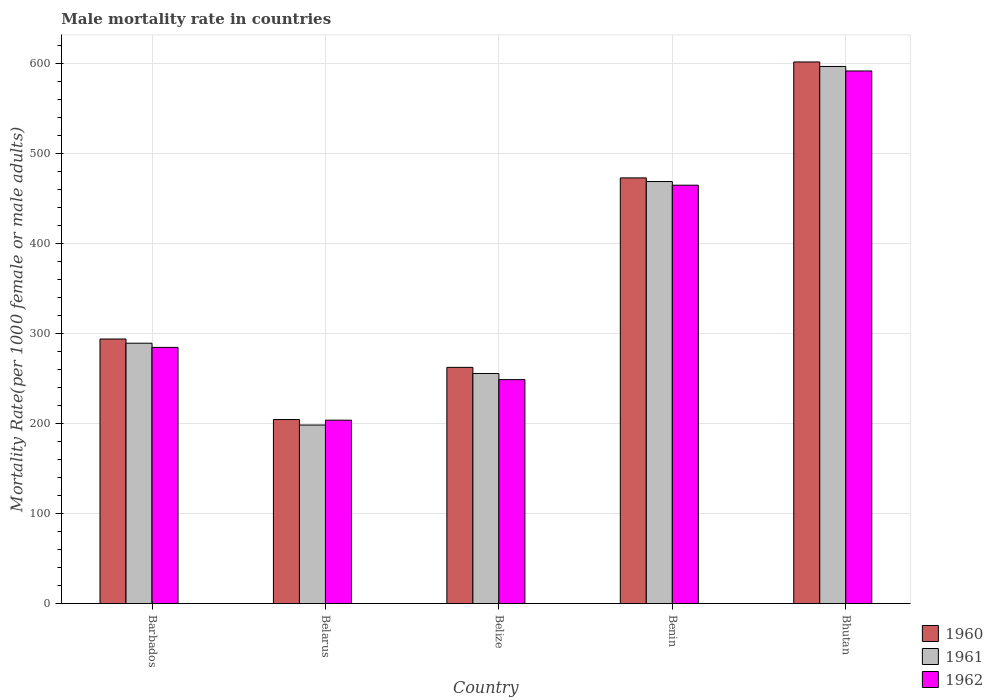Are the number of bars per tick equal to the number of legend labels?
Make the answer very short. Yes. How many bars are there on the 3rd tick from the right?
Your answer should be very brief. 3. What is the label of the 2nd group of bars from the left?
Provide a short and direct response. Belarus. What is the male mortality rate in 1960 in Benin?
Offer a very short reply. 473.24. Across all countries, what is the maximum male mortality rate in 1960?
Give a very brief answer. 602.1. Across all countries, what is the minimum male mortality rate in 1961?
Provide a succinct answer. 198.55. In which country was the male mortality rate in 1960 maximum?
Provide a short and direct response. Bhutan. In which country was the male mortality rate in 1961 minimum?
Offer a terse response. Belarus. What is the total male mortality rate in 1960 in the graph?
Keep it short and to the point. 1836.76. What is the difference between the male mortality rate in 1960 in Barbados and that in Belarus?
Provide a short and direct response. 89.49. What is the difference between the male mortality rate in 1962 in Bhutan and the male mortality rate in 1960 in Belarus?
Offer a terse response. 387.43. What is the average male mortality rate in 1962 per country?
Ensure brevity in your answer.  358.99. What is the difference between the male mortality rate of/in 1961 and male mortality rate of/in 1962 in Barbados?
Offer a very short reply. 4.65. What is the ratio of the male mortality rate in 1962 in Barbados to that in Belarus?
Provide a succinct answer. 1.4. Is the male mortality rate in 1961 in Barbados less than that in Belize?
Offer a terse response. No. Is the difference between the male mortality rate in 1961 in Barbados and Belize greater than the difference between the male mortality rate in 1962 in Barbados and Belize?
Offer a very short reply. No. What is the difference between the highest and the second highest male mortality rate in 1960?
Ensure brevity in your answer.  -128.86. What is the difference between the highest and the lowest male mortality rate in 1961?
Your answer should be very brief. 398.54. Is the sum of the male mortality rate in 1962 in Barbados and Belarus greater than the maximum male mortality rate in 1961 across all countries?
Your answer should be compact. No. Are all the bars in the graph horizontal?
Your response must be concise. No. Does the graph contain any zero values?
Give a very brief answer. No. Does the graph contain grids?
Your answer should be very brief. Yes. What is the title of the graph?
Your answer should be very brief. Male mortality rate in countries. What is the label or title of the X-axis?
Your answer should be very brief. Country. What is the label or title of the Y-axis?
Your response must be concise. Mortality Rate(per 1000 female or male adults). What is the Mortality Rate(per 1000 female or male adults) of 1960 in Barbados?
Offer a very short reply. 294.14. What is the Mortality Rate(per 1000 female or male adults) of 1961 in Barbados?
Offer a very short reply. 289.49. What is the Mortality Rate(per 1000 female or male adults) in 1962 in Barbados?
Offer a very short reply. 284.83. What is the Mortality Rate(per 1000 female or male adults) of 1960 in Belarus?
Ensure brevity in your answer.  204.65. What is the Mortality Rate(per 1000 female or male adults) of 1961 in Belarus?
Give a very brief answer. 198.55. What is the Mortality Rate(per 1000 female or male adults) of 1962 in Belarus?
Give a very brief answer. 203.93. What is the Mortality Rate(per 1000 female or male adults) of 1960 in Belize?
Make the answer very short. 262.64. What is the Mortality Rate(per 1000 female or male adults) of 1961 in Belize?
Keep it short and to the point. 255.81. What is the Mortality Rate(per 1000 female or male adults) in 1962 in Belize?
Give a very brief answer. 248.99. What is the Mortality Rate(per 1000 female or male adults) of 1960 in Benin?
Your response must be concise. 473.24. What is the Mortality Rate(per 1000 female or male adults) in 1961 in Benin?
Provide a succinct answer. 469.18. What is the Mortality Rate(per 1000 female or male adults) in 1962 in Benin?
Offer a terse response. 465.12. What is the Mortality Rate(per 1000 female or male adults) of 1960 in Bhutan?
Your response must be concise. 602.1. What is the Mortality Rate(per 1000 female or male adults) in 1961 in Bhutan?
Provide a short and direct response. 597.09. What is the Mortality Rate(per 1000 female or male adults) of 1962 in Bhutan?
Ensure brevity in your answer.  592.08. Across all countries, what is the maximum Mortality Rate(per 1000 female or male adults) in 1960?
Ensure brevity in your answer.  602.1. Across all countries, what is the maximum Mortality Rate(per 1000 female or male adults) in 1961?
Give a very brief answer. 597.09. Across all countries, what is the maximum Mortality Rate(per 1000 female or male adults) of 1962?
Your answer should be very brief. 592.08. Across all countries, what is the minimum Mortality Rate(per 1000 female or male adults) of 1960?
Your answer should be very brief. 204.65. Across all countries, what is the minimum Mortality Rate(per 1000 female or male adults) of 1961?
Give a very brief answer. 198.55. Across all countries, what is the minimum Mortality Rate(per 1000 female or male adults) of 1962?
Provide a short and direct response. 203.93. What is the total Mortality Rate(per 1000 female or male adults) in 1960 in the graph?
Offer a terse response. 1836.76. What is the total Mortality Rate(per 1000 female or male adults) in 1961 in the graph?
Offer a very short reply. 1810.12. What is the total Mortality Rate(per 1000 female or male adults) in 1962 in the graph?
Keep it short and to the point. 1794.96. What is the difference between the Mortality Rate(per 1000 female or male adults) of 1960 in Barbados and that in Belarus?
Your response must be concise. 89.49. What is the difference between the Mortality Rate(per 1000 female or male adults) of 1961 in Barbados and that in Belarus?
Keep it short and to the point. 90.94. What is the difference between the Mortality Rate(per 1000 female or male adults) in 1962 in Barbados and that in Belarus?
Your answer should be compact. 80.91. What is the difference between the Mortality Rate(per 1000 female or male adults) in 1960 in Barbados and that in Belize?
Your response must be concise. 31.5. What is the difference between the Mortality Rate(per 1000 female or male adults) of 1961 in Barbados and that in Belize?
Keep it short and to the point. 33.67. What is the difference between the Mortality Rate(per 1000 female or male adults) of 1962 in Barbados and that in Belize?
Offer a very short reply. 35.84. What is the difference between the Mortality Rate(per 1000 female or male adults) in 1960 in Barbados and that in Benin?
Your answer should be very brief. -179.1. What is the difference between the Mortality Rate(per 1000 female or male adults) of 1961 in Barbados and that in Benin?
Your response must be concise. -179.69. What is the difference between the Mortality Rate(per 1000 female or male adults) of 1962 in Barbados and that in Benin?
Ensure brevity in your answer.  -180.29. What is the difference between the Mortality Rate(per 1000 female or male adults) of 1960 in Barbados and that in Bhutan?
Make the answer very short. -307.96. What is the difference between the Mortality Rate(per 1000 female or male adults) of 1961 in Barbados and that in Bhutan?
Offer a terse response. -307.6. What is the difference between the Mortality Rate(per 1000 female or male adults) in 1962 in Barbados and that in Bhutan?
Make the answer very short. -307.25. What is the difference between the Mortality Rate(per 1000 female or male adults) in 1960 in Belarus and that in Belize?
Ensure brevity in your answer.  -57.99. What is the difference between the Mortality Rate(per 1000 female or male adults) in 1961 in Belarus and that in Belize?
Keep it short and to the point. -57.27. What is the difference between the Mortality Rate(per 1000 female or male adults) of 1962 in Belarus and that in Belize?
Offer a very short reply. -45.06. What is the difference between the Mortality Rate(per 1000 female or male adults) in 1960 in Belarus and that in Benin?
Provide a short and direct response. -268.59. What is the difference between the Mortality Rate(per 1000 female or male adults) of 1961 in Belarus and that in Benin?
Your response must be concise. -270.63. What is the difference between the Mortality Rate(per 1000 female or male adults) of 1962 in Belarus and that in Benin?
Keep it short and to the point. -261.19. What is the difference between the Mortality Rate(per 1000 female or male adults) of 1960 in Belarus and that in Bhutan?
Keep it short and to the point. -397.45. What is the difference between the Mortality Rate(per 1000 female or male adults) of 1961 in Belarus and that in Bhutan?
Make the answer very short. -398.54. What is the difference between the Mortality Rate(per 1000 female or male adults) in 1962 in Belarus and that in Bhutan?
Offer a very short reply. -388.15. What is the difference between the Mortality Rate(per 1000 female or male adults) of 1960 in Belize and that in Benin?
Give a very brief answer. -210.6. What is the difference between the Mortality Rate(per 1000 female or male adults) in 1961 in Belize and that in Benin?
Keep it short and to the point. -213.37. What is the difference between the Mortality Rate(per 1000 female or male adults) of 1962 in Belize and that in Benin?
Your answer should be very brief. -216.13. What is the difference between the Mortality Rate(per 1000 female or male adults) in 1960 in Belize and that in Bhutan?
Provide a short and direct response. -339.46. What is the difference between the Mortality Rate(per 1000 female or male adults) of 1961 in Belize and that in Bhutan?
Ensure brevity in your answer.  -341.27. What is the difference between the Mortality Rate(per 1000 female or male adults) in 1962 in Belize and that in Bhutan?
Offer a terse response. -343.09. What is the difference between the Mortality Rate(per 1000 female or male adults) in 1960 in Benin and that in Bhutan?
Make the answer very short. -128.86. What is the difference between the Mortality Rate(per 1000 female or male adults) of 1961 in Benin and that in Bhutan?
Offer a very short reply. -127.91. What is the difference between the Mortality Rate(per 1000 female or male adults) of 1962 in Benin and that in Bhutan?
Your answer should be compact. -126.96. What is the difference between the Mortality Rate(per 1000 female or male adults) in 1960 in Barbados and the Mortality Rate(per 1000 female or male adults) in 1961 in Belarus?
Offer a very short reply. 95.59. What is the difference between the Mortality Rate(per 1000 female or male adults) in 1960 in Barbados and the Mortality Rate(per 1000 female or male adults) in 1962 in Belarus?
Make the answer very short. 90.21. What is the difference between the Mortality Rate(per 1000 female or male adults) of 1961 in Barbados and the Mortality Rate(per 1000 female or male adults) of 1962 in Belarus?
Your answer should be very brief. 85.56. What is the difference between the Mortality Rate(per 1000 female or male adults) of 1960 in Barbados and the Mortality Rate(per 1000 female or male adults) of 1961 in Belize?
Offer a terse response. 38.32. What is the difference between the Mortality Rate(per 1000 female or male adults) in 1960 in Barbados and the Mortality Rate(per 1000 female or male adults) in 1962 in Belize?
Make the answer very short. 45.14. What is the difference between the Mortality Rate(per 1000 female or male adults) in 1961 in Barbados and the Mortality Rate(per 1000 female or male adults) in 1962 in Belize?
Provide a short and direct response. 40.49. What is the difference between the Mortality Rate(per 1000 female or male adults) of 1960 in Barbados and the Mortality Rate(per 1000 female or male adults) of 1961 in Benin?
Provide a succinct answer. -175.04. What is the difference between the Mortality Rate(per 1000 female or male adults) of 1960 in Barbados and the Mortality Rate(per 1000 female or male adults) of 1962 in Benin?
Your answer should be compact. -170.99. What is the difference between the Mortality Rate(per 1000 female or male adults) in 1961 in Barbados and the Mortality Rate(per 1000 female or male adults) in 1962 in Benin?
Keep it short and to the point. -175.64. What is the difference between the Mortality Rate(per 1000 female or male adults) of 1960 in Barbados and the Mortality Rate(per 1000 female or male adults) of 1961 in Bhutan?
Give a very brief answer. -302.95. What is the difference between the Mortality Rate(per 1000 female or male adults) in 1960 in Barbados and the Mortality Rate(per 1000 female or male adults) in 1962 in Bhutan?
Offer a terse response. -297.94. What is the difference between the Mortality Rate(per 1000 female or male adults) of 1961 in Barbados and the Mortality Rate(per 1000 female or male adults) of 1962 in Bhutan?
Offer a very short reply. -302.6. What is the difference between the Mortality Rate(per 1000 female or male adults) in 1960 in Belarus and the Mortality Rate(per 1000 female or male adults) in 1961 in Belize?
Offer a terse response. -51.17. What is the difference between the Mortality Rate(per 1000 female or male adults) in 1960 in Belarus and the Mortality Rate(per 1000 female or male adults) in 1962 in Belize?
Make the answer very short. -44.35. What is the difference between the Mortality Rate(per 1000 female or male adults) of 1961 in Belarus and the Mortality Rate(per 1000 female or male adults) of 1962 in Belize?
Give a very brief answer. -50.44. What is the difference between the Mortality Rate(per 1000 female or male adults) in 1960 in Belarus and the Mortality Rate(per 1000 female or male adults) in 1961 in Benin?
Offer a terse response. -264.53. What is the difference between the Mortality Rate(per 1000 female or male adults) in 1960 in Belarus and the Mortality Rate(per 1000 female or male adults) in 1962 in Benin?
Keep it short and to the point. -260.48. What is the difference between the Mortality Rate(per 1000 female or male adults) in 1961 in Belarus and the Mortality Rate(per 1000 female or male adults) in 1962 in Benin?
Ensure brevity in your answer.  -266.57. What is the difference between the Mortality Rate(per 1000 female or male adults) of 1960 in Belarus and the Mortality Rate(per 1000 female or male adults) of 1961 in Bhutan?
Provide a succinct answer. -392.44. What is the difference between the Mortality Rate(per 1000 female or male adults) of 1960 in Belarus and the Mortality Rate(per 1000 female or male adults) of 1962 in Bhutan?
Your response must be concise. -387.43. What is the difference between the Mortality Rate(per 1000 female or male adults) of 1961 in Belarus and the Mortality Rate(per 1000 female or male adults) of 1962 in Bhutan?
Your answer should be compact. -393.53. What is the difference between the Mortality Rate(per 1000 female or male adults) in 1960 in Belize and the Mortality Rate(per 1000 female or male adults) in 1961 in Benin?
Your answer should be very brief. -206.54. What is the difference between the Mortality Rate(per 1000 female or male adults) in 1960 in Belize and the Mortality Rate(per 1000 female or male adults) in 1962 in Benin?
Your response must be concise. -202.49. What is the difference between the Mortality Rate(per 1000 female or male adults) of 1961 in Belize and the Mortality Rate(per 1000 female or male adults) of 1962 in Benin?
Ensure brevity in your answer.  -209.31. What is the difference between the Mortality Rate(per 1000 female or male adults) of 1960 in Belize and the Mortality Rate(per 1000 female or male adults) of 1961 in Bhutan?
Offer a very short reply. -334.45. What is the difference between the Mortality Rate(per 1000 female or male adults) of 1960 in Belize and the Mortality Rate(per 1000 female or male adults) of 1962 in Bhutan?
Provide a succinct answer. -329.44. What is the difference between the Mortality Rate(per 1000 female or male adults) of 1961 in Belize and the Mortality Rate(per 1000 female or male adults) of 1962 in Bhutan?
Your answer should be very brief. -336.26. What is the difference between the Mortality Rate(per 1000 female or male adults) of 1960 in Benin and the Mortality Rate(per 1000 female or male adults) of 1961 in Bhutan?
Give a very brief answer. -123.85. What is the difference between the Mortality Rate(per 1000 female or male adults) of 1960 in Benin and the Mortality Rate(per 1000 female or male adults) of 1962 in Bhutan?
Make the answer very short. -118.84. What is the difference between the Mortality Rate(per 1000 female or male adults) of 1961 in Benin and the Mortality Rate(per 1000 female or male adults) of 1962 in Bhutan?
Give a very brief answer. -122.9. What is the average Mortality Rate(per 1000 female or male adults) in 1960 per country?
Give a very brief answer. 367.35. What is the average Mortality Rate(per 1000 female or male adults) of 1961 per country?
Make the answer very short. 362.02. What is the average Mortality Rate(per 1000 female or male adults) in 1962 per country?
Keep it short and to the point. 358.99. What is the difference between the Mortality Rate(per 1000 female or male adults) in 1960 and Mortality Rate(per 1000 female or male adults) in 1961 in Barbados?
Provide a succinct answer. 4.65. What is the difference between the Mortality Rate(per 1000 female or male adults) of 1960 and Mortality Rate(per 1000 female or male adults) of 1962 in Barbados?
Provide a succinct answer. 9.3. What is the difference between the Mortality Rate(per 1000 female or male adults) of 1961 and Mortality Rate(per 1000 female or male adults) of 1962 in Barbados?
Ensure brevity in your answer.  4.65. What is the difference between the Mortality Rate(per 1000 female or male adults) in 1960 and Mortality Rate(per 1000 female or male adults) in 1961 in Belarus?
Provide a short and direct response. 6.1. What is the difference between the Mortality Rate(per 1000 female or male adults) of 1960 and Mortality Rate(per 1000 female or male adults) of 1962 in Belarus?
Your answer should be very brief. 0.72. What is the difference between the Mortality Rate(per 1000 female or male adults) in 1961 and Mortality Rate(per 1000 female or male adults) in 1962 in Belarus?
Provide a short and direct response. -5.38. What is the difference between the Mortality Rate(per 1000 female or male adults) in 1960 and Mortality Rate(per 1000 female or male adults) in 1961 in Belize?
Offer a terse response. 6.82. What is the difference between the Mortality Rate(per 1000 female or male adults) of 1960 and Mortality Rate(per 1000 female or male adults) of 1962 in Belize?
Give a very brief answer. 13.64. What is the difference between the Mortality Rate(per 1000 female or male adults) in 1961 and Mortality Rate(per 1000 female or male adults) in 1962 in Belize?
Provide a succinct answer. 6.82. What is the difference between the Mortality Rate(per 1000 female or male adults) in 1960 and Mortality Rate(per 1000 female or male adults) in 1961 in Benin?
Offer a terse response. 4.06. What is the difference between the Mortality Rate(per 1000 female or male adults) of 1960 and Mortality Rate(per 1000 female or male adults) of 1962 in Benin?
Provide a short and direct response. 8.11. What is the difference between the Mortality Rate(per 1000 female or male adults) of 1961 and Mortality Rate(per 1000 female or male adults) of 1962 in Benin?
Your response must be concise. 4.06. What is the difference between the Mortality Rate(per 1000 female or male adults) of 1960 and Mortality Rate(per 1000 female or male adults) of 1961 in Bhutan?
Your answer should be compact. 5.01. What is the difference between the Mortality Rate(per 1000 female or male adults) of 1960 and Mortality Rate(per 1000 female or male adults) of 1962 in Bhutan?
Your answer should be compact. 10.02. What is the difference between the Mortality Rate(per 1000 female or male adults) in 1961 and Mortality Rate(per 1000 female or male adults) in 1962 in Bhutan?
Your answer should be compact. 5.01. What is the ratio of the Mortality Rate(per 1000 female or male adults) of 1960 in Barbados to that in Belarus?
Your answer should be compact. 1.44. What is the ratio of the Mortality Rate(per 1000 female or male adults) of 1961 in Barbados to that in Belarus?
Your response must be concise. 1.46. What is the ratio of the Mortality Rate(per 1000 female or male adults) in 1962 in Barbados to that in Belarus?
Offer a terse response. 1.4. What is the ratio of the Mortality Rate(per 1000 female or male adults) of 1960 in Barbados to that in Belize?
Your answer should be very brief. 1.12. What is the ratio of the Mortality Rate(per 1000 female or male adults) of 1961 in Barbados to that in Belize?
Give a very brief answer. 1.13. What is the ratio of the Mortality Rate(per 1000 female or male adults) of 1962 in Barbados to that in Belize?
Your answer should be compact. 1.14. What is the ratio of the Mortality Rate(per 1000 female or male adults) in 1960 in Barbados to that in Benin?
Keep it short and to the point. 0.62. What is the ratio of the Mortality Rate(per 1000 female or male adults) of 1961 in Barbados to that in Benin?
Your response must be concise. 0.62. What is the ratio of the Mortality Rate(per 1000 female or male adults) in 1962 in Barbados to that in Benin?
Offer a terse response. 0.61. What is the ratio of the Mortality Rate(per 1000 female or male adults) of 1960 in Barbados to that in Bhutan?
Provide a succinct answer. 0.49. What is the ratio of the Mortality Rate(per 1000 female or male adults) of 1961 in Barbados to that in Bhutan?
Your answer should be compact. 0.48. What is the ratio of the Mortality Rate(per 1000 female or male adults) of 1962 in Barbados to that in Bhutan?
Your answer should be compact. 0.48. What is the ratio of the Mortality Rate(per 1000 female or male adults) of 1960 in Belarus to that in Belize?
Offer a very short reply. 0.78. What is the ratio of the Mortality Rate(per 1000 female or male adults) in 1961 in Belarus to that in Belize?
Keep it short and to the point. 0.78. What is the ratio of the Mortality Rate(per 1000 female or male adults) of 1962 in Belarus to that in Belize?
Offer a terse response. 0.82. What is the ratio of the Mortality Rate(per 1000 female or male adults) of 1960 in Belarus to that in Benin?
Offer a very short reply. 0.43. What is the ratio of the Mortality Rate(per 1000 female or male adults) in 1961 in Belarus to that in Benin?
Your response must be concise. 0.42. What is the ratio of the Mortality Rate(per 1000 female or male adults) of 1962 in Belarus to that in Benin?
Your response must be concise. 0.44. What is the ratio of the Mortality Rate(per 1000 female or male adults) in 1960 in Belarus to that in Bhutan?
Offer a terse response. 0.34. What is the ratio of the Mortality Rate(per 1000 female or male adults) of 1961 in Belarus to that in Bhutan?
Make the answer very short. 0.33. What is the ratio of the Mortality Rate(per 1000 female or male adults) in 1962 in Belarus to that in Bhutan?
Offer a very short reply. 0.34. What is the ratio of the Mortality Rate(per 1000 female or male adults) in 1960 in Belize to that in Benin?
Make the answer very short. 0.56. What is the ratio of the Mortality Rate(per 1000 female or male adults) in 1961 in Belize to that in Benin?
Your response must be concise. 0.55. What is the ratio of the Mortality Rate(per 1000 female or male adults) of 1962 in Belize to that in Benin?
Make the answer very short. 0.54. What is the ratio of the Mortality Rate(per 1000 female or male adults) of 1960 in Belize to that in Bhutan?
Your answer should be very brief. 0.44. What is the ratio of the Mortality Rate(per 1000 female or male adults) of 1961 in Belize to that in Bhutan?
Keep it short and to the point. 0.43. What is the ratio of the Mortality Rate(per 1000 female or male adults) in 1962 in Belize to that in Bhutan?
Make the answer very short. 0.42. What is the ratio of the Mortality Rate(per 1000 female or male adults) of 1960 in Benin to that in Bhutan?
Provide a succinct answer. 0.79. What is the ratio of the Mortality Rate(per 1000 female or male adults) of 1961 in Benin to that in Bhutan?
Your response must be concise. 0.79. What is the ratio of the Mortality Rate(per 1000 female or male adults) in 1962 in Benin to that in Bhutan?
Ensure brevity in your answer.  0.79. What is the difference between the highest and the second highest Mortality Rate(per 1000 female or male adults) of 1960?
Give a very brief answer. 128.86. What is the difference between the highest and the second highest Mortality Rate(per 1000 female or male adults) in 1961?
Offer a terse response. 127.91. What is the difference between the highest and the second highest Mortality Rate(per 1000 female or male adults) of 1962?
Provide a succinct answer. 126.96. What is the difference between the highest and the lowest Mortality Rate(per 1000 female or male adults) in 1960?
Provide a short and direct response. 397.45. What is the difference between the highest and the lowest Mortality Rate(per 1000 female or male adults) of 1961?
Give a very brief answer. 398.54. What is the difference between the highest and the lowest Mortality Rate(per 1000 female or male adults) in 1962?
Ensure brevity in your answer.  388.15. 